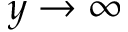<formula> <loc_0><loc_0><loc_500><loc_500>y \to \infty</formula> 